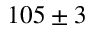<formula> <loc_0><loc_0><loc_500><loc_500>1 0 5 \pm 3</formula> 